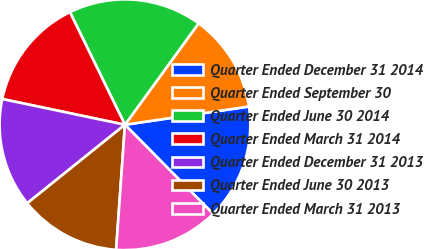<chart> <loc_0><loc_0><loc_500><loc_500><pie_chart><fcel>Quarter Ended December 31 2014<fcel>Quarter Ended September 30<fcel>Quarter Ended June 30 2014<fcel>Quarter Ended March 31 2014<fcel>Quarter Ended December 31 2013<fcel>Quarter Ended June 30 2013<fcel>Quarter Ended March 31 2013<nl><fcel>14.91%<fcel>12.68%<fcel>17.23%<fcel>14.48%<fcel>14.06%<fcel>13.11%<fcel>13.53%<nl></chart> 